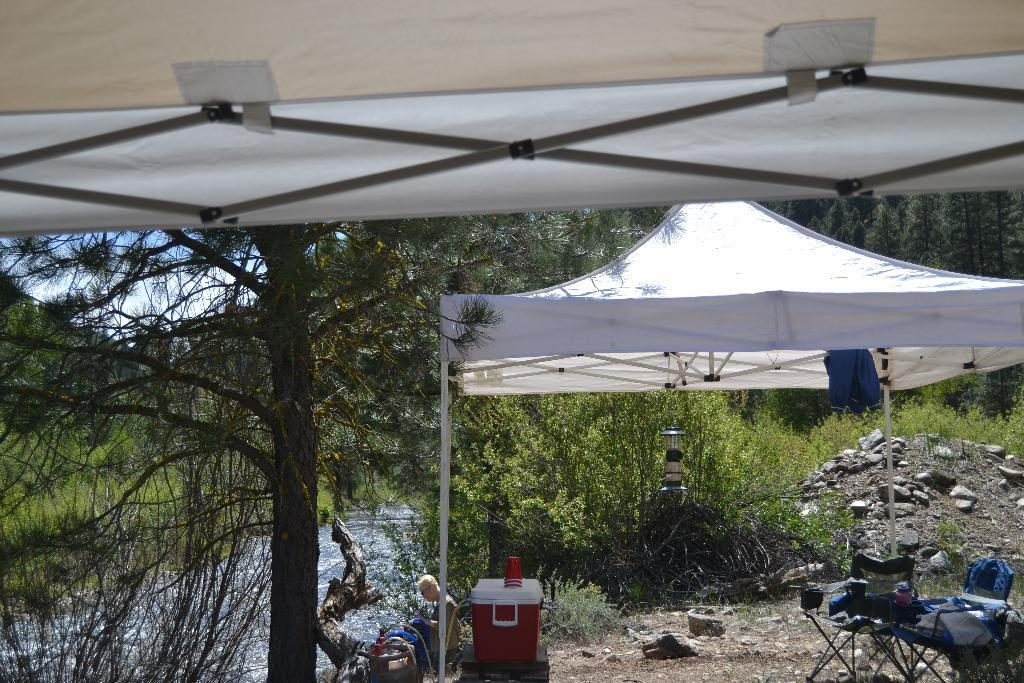What is present in the image? There is a person, a container, a glass, a table, cloths, stones, water, a tree, a tent, and the sky visible in the image. Can you describe the person in the image? The person is wearing clothes and goggles. What is the person holding or interacting with in the image? The person is not holding or interacting with any specific object in the image. What is the container in the image used for? The facts do not specify the purpose of the container. What is the texture of the cloths in the image? The facts do not specify the texture of the cloths. What is the color of the water in the image? The facts do not specify the color of the water. What type of slope can be seen in the image? There is no slope present in the image. Is the person in the image sinking into quicksand? There is no quicksand present in the image. 